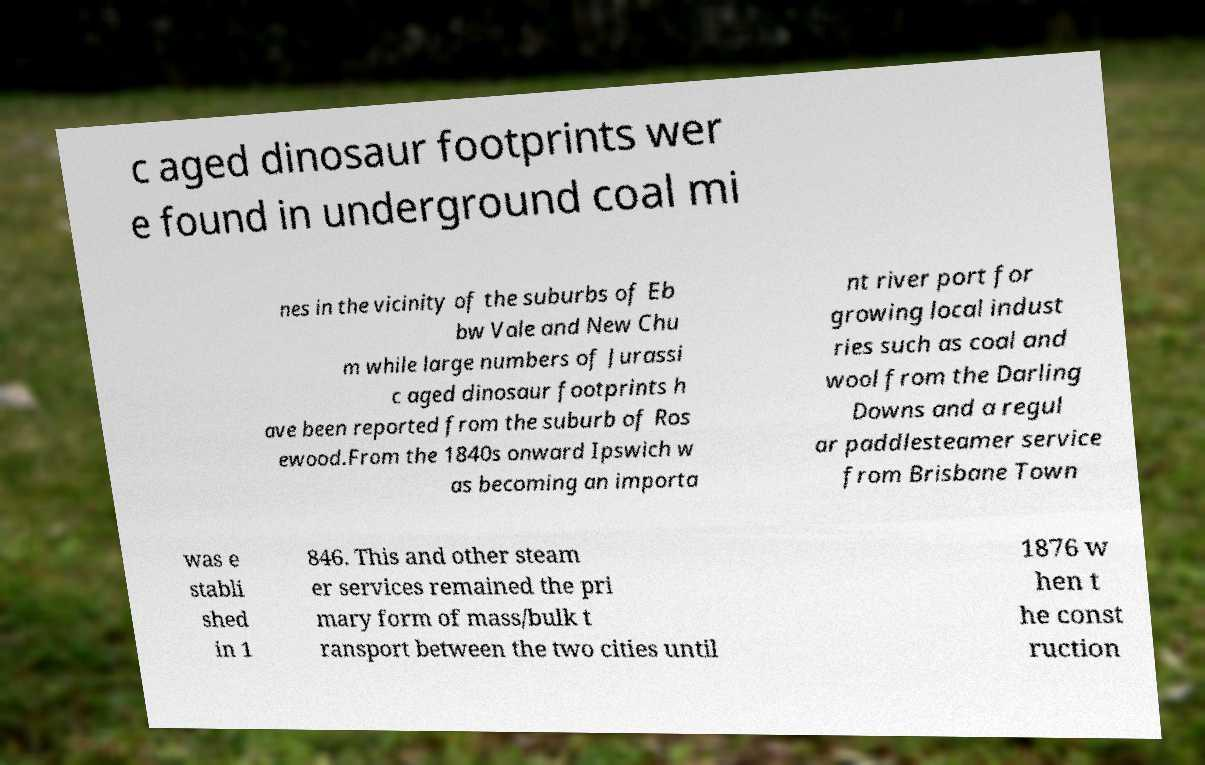Can you read and provide the text displayed in the image?This photo seems to have some interesting text. Can you extract and type it out for me? c aged dinosaur footprints wer e found in underground coal mi nes in the vicinity of the suburbs of Eb bw Vale and New Chu m while large numbers of Jurassi c aged dinosaur footprints h ave been reported from the suburb of Ros ewood.From the 1840s onward Ipswich w as becoming an importa nt river port for growing local indust ries such as coal and wool from the Darling Downs and a regul ar paddlesteamer service from Brisbane Town was e stabli shed in 1 846. This and other steam er services remained the pri mary form of mass/bulk t ransport between the two cities until 1876 w hen t he const ruction 